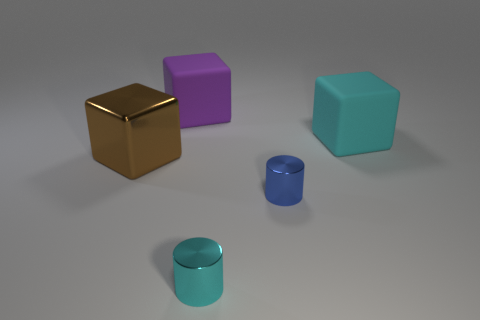What size is the brown thing that is made of the same material as the cyan cylinder?
Ensure brevity in your answer.  Large. What color is the big rubber object that is on the left side of the big matte thing that is in front of the purple rubber thing?
Make the answer very short. Purple. There is a big brown metal object; is its shape the same as the big matte object on the right side of the big purple cube?
Keep it short and to the point. Yes. How many cyan metallic things are the same size as the cyan matte thing?
Your response must be concise. 0. There is another thing that is the same shape as the cyan shiny thing; what is its material?
Your answer should be very brief. Metal. There is a big matte block in front of the big purple block; is it the same color as the tiny metallic cylinder in front of the blue metal object?
Keep it short and to the point. Yes. There is a large object that is right of the cyan shiny object; what shape is it?
Offer a very short reply. Cube. What color is the metallic block?
Give a very brief answer. Brown. The big thing that is the same material as the tiny cyan cylinder is what shape?
Provide a short and direct response. Cube. Does the cube that is left of the purple cube have the same size as the blue cylinder?
Offer a very short reply. No. 